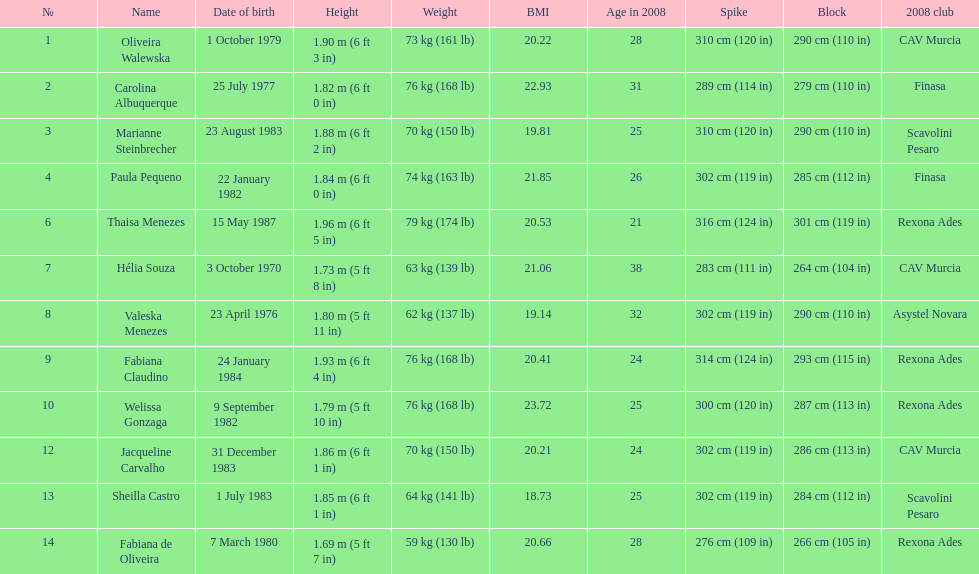Whose weight is the heaviest among the following: fabiana de oliveira, helia souza, or sheilla castro? Sheilla Castro. 